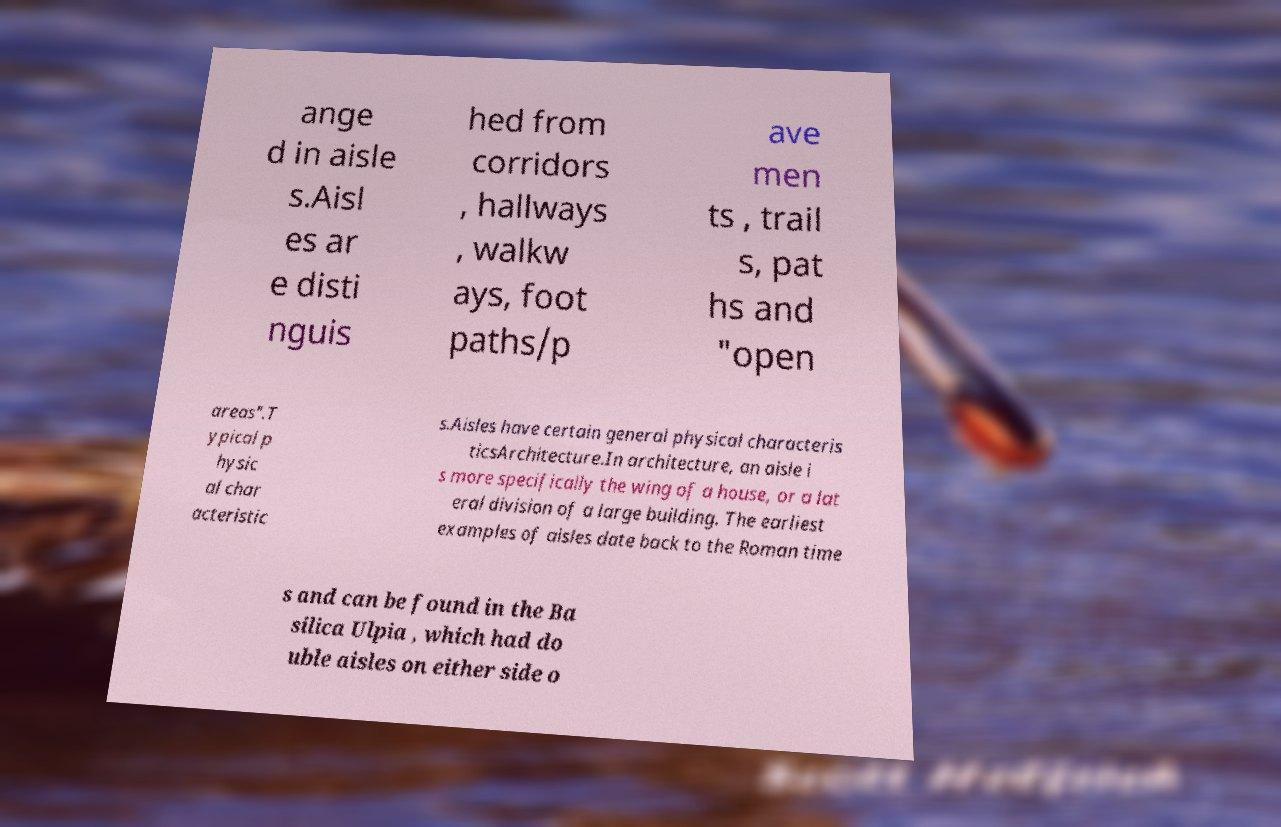Please read and relay the text visible in this image. What does it say? ange d in aisle s.Aisl es ar e disti nguis hed from corridors , hallways , walkw ays, foot paths/p ave men ts , trail s, pat hs and "open areas".T ypical p hysic al char acteristic s.Aisles have certain general physical characteris ticsArchitecture.In architecture, an aisle i s more specifically the wing of a house, or a lat eral division of a large building. The earliest examples of aisles date back to the Roman time s and can be found in the Ba silica Ulpia , which had do uble aisles on either side o 